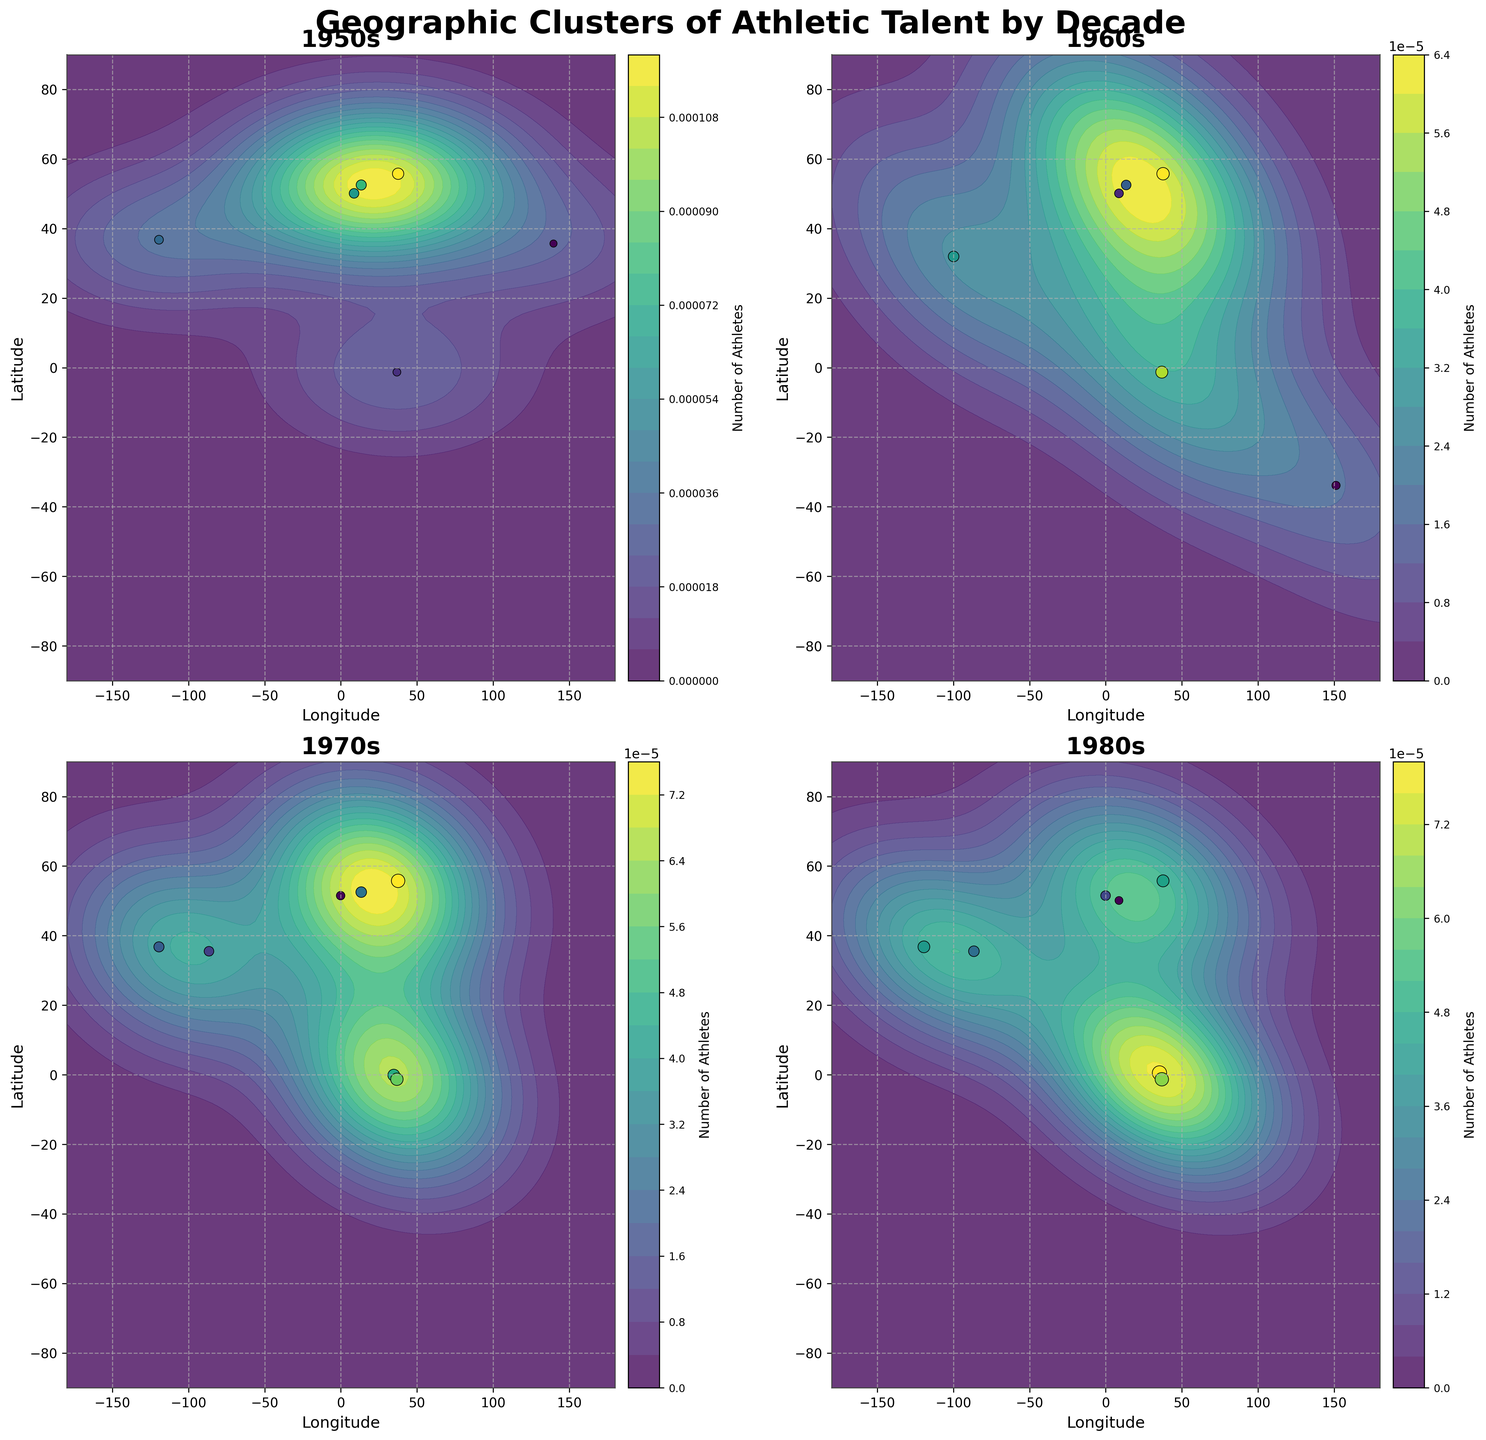What does the title of the figure indicate? The title "Geographic Clusters of Athletic Talent by Decade" suggests that the figure displays the distribution and density of athletes' birthplaces globally over different decades.
Answer: Geographic Clusters of Athletic Talent by Decade How are the decades represented in the figure? The decades are represented in separate subplots, with each subplot showing the data for a specific decade (1950s, 1960s, 1970s, and 1980s).
Answer: Separate subplots Which decade has the highest density of athletes near Moscow? By observing the contour density in each subplot, the 1970s and 1980s have noticeable higher density near Moscow compared to the previous decades.
Answer: 1970s and 1980s How does the number of athletes in Nairobi change across the decades? By looking at the scatter points and the color intensity, Nairobi shows an increase in the number of athletes from the 1950s to the 1980s, with the density of athletes becoming higher in later decades.
Answer: Increases Which region shows the highest increase in athlete density from the 1950s to the 1980s? Comparatively, the region around Nairobi (including Eldoret) shows a significant rise in athlete density, evident from the scatter sizes and density contours that become more prominent over the decades.
Answer: Nairobi and Eldoret What can be inferred about California's contribution to athletic talent over the decades? California consistently shows a considerable density of athletes across all decades, indicating a stable and significant contribution throughout the periods.
Answer: Consistent and stable contribution Which region had the highest number of athletes in the 1950s? Moscow exhibits the highest density and number of athletes in the 1950s subplot, as indicated by the largest scatter point and densest contour.
Answer: Moscow How does the distribution of athletes in Germany change after the 1960s? After the 1960s, the distribution spreads, with noticeable densities in both East and West Germany in earlier decades; in the 1980s, only West Germany maintains noticeable athlete density.
Answer: Spread, then focus on West Germany Between the 1950s and 1980s, which region experienced a noticeable decline in athlete density? East Germany shows a decline in athlete density with a strong presence in the 1950s and 1960s but reduced density in later decades.
Answer: East Germany 